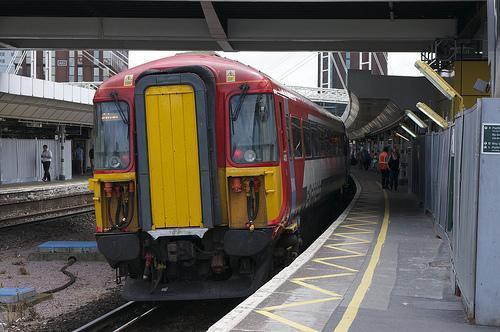How many windows are on the front of the train?
Give a very brief answer. 2. 